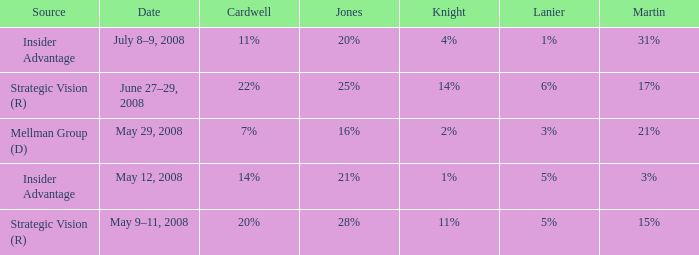What kind of source contains a cardwell of 20%? Strategic Vision (R). 